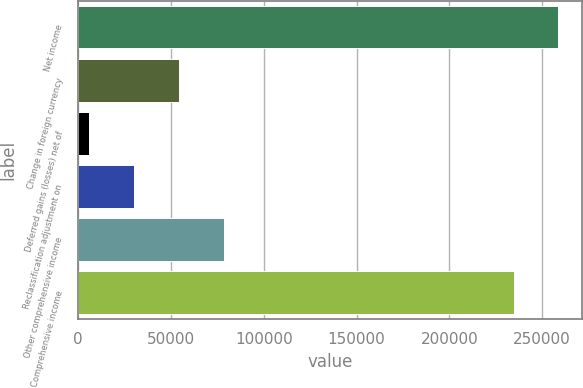Convert chart. <chart><loc_0><loc_0><loc_500><loc_500><bar_chart><fcel>Net income<fcel>Change in foreign currency<fcel>Deferred gains (losses) net of<fcel>Reclassification adjustment on<fcel>Other comprehensive income<fcel>Comprehensive income<nl><fcel>258740<fcel>54405.6<fcel>6057<fcel>30231.3<fcel>78579.9<fcel>234566<nl></chart> 